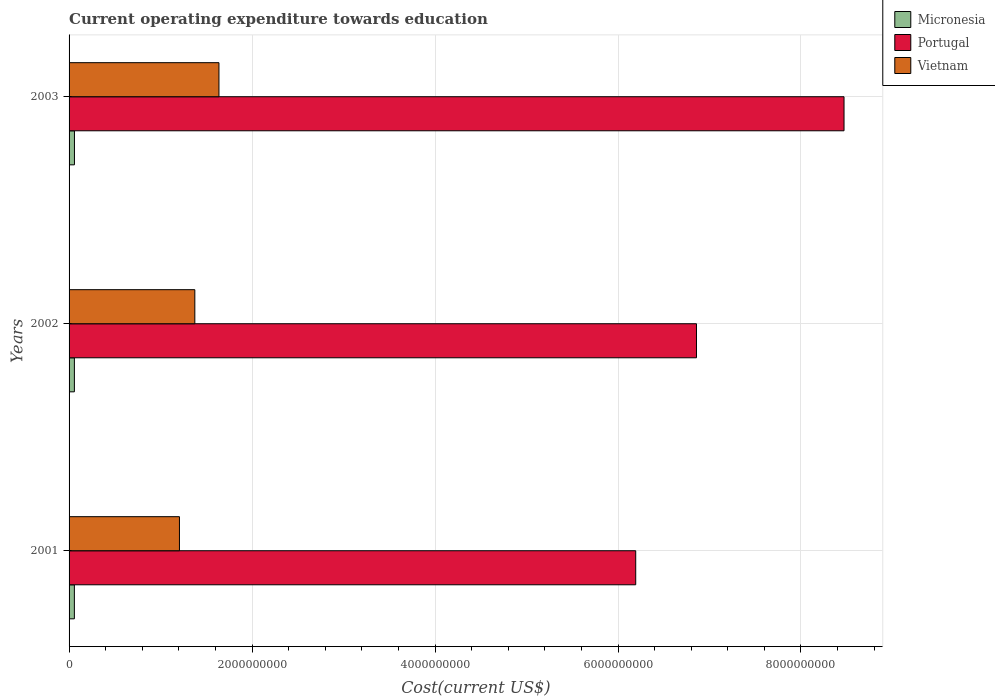How many different coloured bars are there?
Your answer should be very brief. 3. How many groups of bars are there?
Make the answer very short. 3. Are the number of bars on each tick of the Y-axis equal?
Provide a short and direct response. Yes. How many bars are there on the 3rd tick from the top?
Give a very brief answer. 3. What is the expenditure towards education in Micronesia in 2002?
Give a very brief answer. 5.82e+07. Across all years, what is the maximum expenditure towards education in Micronesia?
Make the answer very short. 5.89e+07. Across all years, what is the minimum expenditure towards education in Micronesia?
Offer a terse response. 5.80e+07. In which year was the expenditure towards education in Micronesia minimum?
Keep it short and to the point. 2001. What is the total expenditure towards education in Micronesia in the graph?
Offer a very short reply. 1.75e+08. What is the difference between the expenditure towards education in Portugal in 2001 and that in 2003?
Give a very brief answer. -2.28e+09. What is the difference between the expenditure towards education in Portugal in 2003 and the expenditure towards education in Micronesia in 2002?
Your response must be concise. 8.41e+09. What is the average expenditure towards education in Portugal per year?
Ensure brevity in your answer.  7.17e+09. In the year 2003, what is the difference between the expenditure towards education in Micronesia and expenditure towards education in Vietnam?
Offer a terse response. -1.58e+09. What is the ratio of the expenditure towards education in Portugal in 2001 to that in 2002?
Keep it short and to the point. 0.9. Is the expenditure towards education in Vietnam in 2001 less than that in 2003?
Your response must be concise. Yes. What is the difference between the highest and the second highest expenditure towards education in Micronesia?
Your response must be concise. 7.07e+05. What is the difference between the highest and the lowest expenditure towards education in Vietnam?
Ensure brevity in your answer.  4.32e+08. What does the 2nd bar from the top in 2003 represents?
Provide a short and direct response. Portugal. What does the 2nd bar from the bottom in 2003 represents?
Your answer should be compact. Portugal. Is it the case that in every year, the sum of the expenditure towards education in Vietnam and expenditure towards education in Portugal is greater than the expenditure towards education in Micronesia?
Your answer should be compact. Yes. Are all the bars in the graph horizontal?
Provide a short and direct response. Yes. How many years are there in the graph?
Provide a succinct answer. 3. How are the legend labels stacked?
Offer a very short reply. Vertical. What is the title of the graph?
Your answer should be very brief. Current operating expenditure towards education. What is the label or title of the X-axis?
Give a very brief answer. Cost(current US$). What is the Cost(current US$) in Micronesia in 2001?
Offer a terse response. 5.80e+07. What is the Cost(current US$) in Portugal in 2001?
Offer a very short reply. 6.19e+09. What is the Cost(current US$) in Vietnam in 2001?
Offer a terse response. 1.21e+09. What is the Cost(current US$) of Micronesia in 2002?
Give a very brief answer. 5.82e+07. What is the Cost(current US$) of Portugal in 2002?
Your response must be concise. 6.86e+09. What is the Cost(current US$) in Vietnam in 2002?
Give a very brief answer. 1.37e+09. What is the Cost(current US$) in Micronesia in 2003?
Offer a terse response. 5.89e+07. What is the Cost(current US$) in Portugal in 2003?
Offer a terse response. 8.47e+09. What is the Cost(current US$) in Vietnam in 2003?
Ensure brevity in your answer.  1.64e+09. Across all years, what is the maximum Cost(current US$) of Micronesia?
Provide a short and direct response. 5.89e+07. Across all years, what is the maximum Cost(current US$) in Portugal?
Provide a short and direct response. 8.47e+09. Across all years, what is the maximum Cost(current US$) in Vietnam?
Make the answer very short. 1.64e+09. Across all years, what is the minimum Cost(current US$) of Micronesia?
Keep it short and to the point. 5.80e+07. Across all years, what is the minimum Cost(current US$) of Portugal?
Provide a succinct answer. 6.19e+09. Across all years, what is the minimum Cost(current US$) in Vietnam?
Your answer should be compact. 1.21e+09. What is the total Cost(current US$) of Micronesia in the graph?
Offer a terse response. 1.75e+08. What is the total Cost(current US$) of Portugal in the graph?
Provide a succinct answer. 2.15e+1. What is the total Cost(current US$) in Vietnam in the graph?
Your answer should be compact. 4.22e+09. What is the difference between the Cost(current US$) of Micronesia in 2001 and that in 2002?
Ensure brevity in your answer.  -2.28e+05. What is the difference between the Cost(current US$) of Portugal in 2001 and that in 2002?
Provide a succinct answer. -6.64e+08. What is the difference between the Cost(current US$) in Vietnam in 2001 and that in 2002?
Your response must be concise. -1.68e+08. What is the difference between the Cost(current US$) in Micronesia in 2001 and that in 2003?
Make the answer very short. -9.35e+05. What is the difference between the Cost(current US$) of Portugal in 2001 and that in 2003?
Your answer should be very brief. -2.28e+09. What is the difference between the Cost(current US$) in Vietnam in 2001 and that in 2003?
Provide a succinct answer. -4.32e+08. What is the difference between the Cost(current US$) in Micronesia in 2002 and that in 2003?
Keep it short and to the point. -7.07e+05. What is the difference between the Cost(current US$) of Portugal in 2002 and that in 2003?
Provide a succinct answer. -1.61e+09. What is the difference between the Cost(current US$) of Vietnam in 2002 and that in 2003?
Your answer should be compact. -2.64e+08. What is the difference between the Cost(current US$) in Micronesia in 2001 and the Cost(current US$) in Portugal in 2002?
Your answer should be compact. -6.80e+09. What is the difference between the Cost(current US$) in Micronesia in 2001 and the Cost(current US$) in Vietnam in 2002?
Your response must be concise. -1.32e+09. What is the difference between the Cost(current US$) of Portugal in 2001 and the Cost(current US$) of Vietnam in 2002?
Provide a succinct answer. 4.82e+09. What is the difference between the Cost(current US$) in Micronesia in 2001 and the Cost(current US$) in Portugal in 2003?
Ensure brevity in your answer.  -8.41e+09. What is the difference between the Cost(current US$) of Micronesia in 2001 and the Cost(current US$) of Vietnam in 2003?
Your response must be concise. -1.58e+09. What is the difference between the Cost(current US$) in Portugal in 2001 and the Cost(current US$) in Vietnam in 2003?
Your answer should be compact. 4.56e+09. What is the difference between the Cost(current US$) of Micronesia in 2002 and the Cost(current US$) of Portugal in 2003?
Offer a terse response. -8.41e+09. What is the difference between the Cost(current US$) of Micronesia in 2002 and the Cost(current US$) of Vietnam in 2003?
Provide a succinct answer. -1.58e+09. What is the difference between the Cost(current US$) of Portugal in 2002 and the Cost(current US$) of Vietnam in 2003?
Make the answer very short. 5.22e+09. What is the average Cost(current US$) in Micronesia per year?
Offer a terse response. 5.83e+07. What is the average Cost(current US$) of Portugal per year?
Offer a very short reply. 7.17e+09. What is the average Cost(current US$) of Vietnam per year?
Provide a succinct answer. 1.41e+09. In the year 2001, what is the difference between the Cost(current US$) in Micronesia and Cost(current US$) in Portugal?
Offer a very short reply. -6.14e+09. In the year 2001, what is the difference between the Cost(current US$) of Micronesia and Cost(current US$) of Vietnam?
Give a very brief answer. -1.15e+09. In the year 2001, what is the difference between the Cost(current US$) in Portugal and Cost(current US$) in Vietnam?
Ensure brevity in your answer.  4.99e+09. In the year 2002, what is the difference between the Cost(current US$) in Micronesia and Cost(current US$) in Portugal?
Provide a short and direct response. -6.80e+09. In the year 2002, what is the difference between the Cost(current US$) of Micronesia and Cost(current US$) of Vietnam?
Offer a very short reply. -1.32e+09. In the year 2002, what is the difference between the Cost(current US$) in Portugal and Cost(current US$) in Vietnam?
Offer a very short reply. 5.48e+09. In the year 2003, what is the difference between the Cost(current US$) of Micronesia and Cost(current US$) of Portugal?
Provide a short and direct response. -8.41e+09. In the year 2003, what is the difference between the Cost(current US$) of Micronesia and Cost(current US$) of Vietnam?
Make the answer very short. -1.58e+09. In the year 2003, what is the difference between the Cost(current US$) in Portugal and Cost(current US$) in Vietnam?
Offer a terse response. 6.83e+09. What is the ratio of the Cost(current US$) of Micronesia in 2001 to that in 2002?
Offer a terse response. 1. What is the ratio of the Cost(current US$) in Portugal in 2001 to that in 2002?
Offer a very short reply. 0.9. What is the ratio of the Cost(current US$) of Vietnam in 2001 to that in 2002?
Offer a very short reply. 0.88. What is the ratio of the Cost(current US$) in Micronesia in 2001 to that in 2003?
Ensure brevity in your answer.  0.98. What is the ratio of the Cost(current US$) of Portugal in 2001 to that in 2003?
Provide a succinct answer. 0.73. What is the ratio of the Cost(current US$) of Vietnam in 2001 to that in 2003?
Provide a succinct answer. 0.74. What is the ratio of the Cost(current US$) in Portugal in 2002 to that in 2003?
Your answer should be compact. 0.81. What is the ratio of the Cost(current US$) of Vietnam in 2002 to that in 2003?
Offer a terse response. 0.84. What is the difference between the highest and the second highest Cost(current US$) in Micronesia?
Give a very brief answer. 7.07e+05. What is the difference between the highest and the second highest Cost(current US$) in Portugal?
Your answer should be very brief. 1.61e+09. What is the difference between the highest and the second highest Cost(current US$) in Vietnam?
Ensure brevity in your answer.  2.64e+08. What is the difference between the highest and the lowest Cost(current US$) in Micronesia?
Provide a short and direct response. 9.35e+05. What is the difference between the highest and the lowest Cost(current US$) of Portugal?
Provide a short and direct response. 2.28e+09. What is the difference between the highest and the lowest Cost(current US$) of Vietnam?
Make the answer very short. 4.32e+08. 